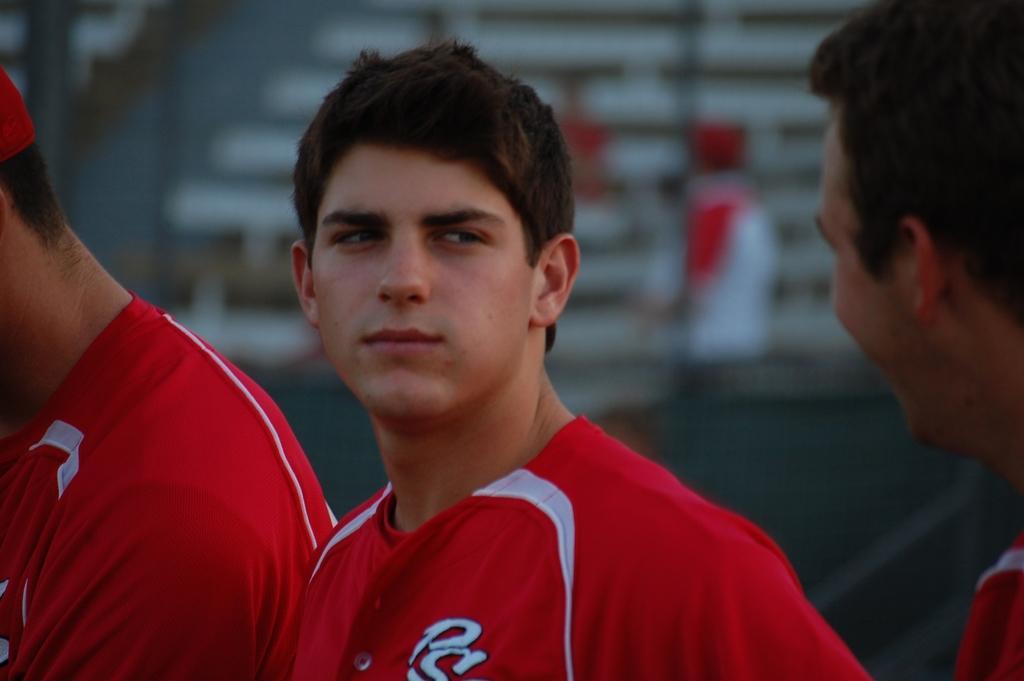Describe this image in one or two sentences. In this image we can see three persons wearing red color t-shirt and the background is blurred. 